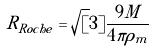Convert formula to latex. <formula><loc_0><loc_0><loc_500><loc_500>R _ { R o c h e } = \sqrt { [ } 3 ] { \frac { 9 M } { 4 \pi \rho _ { m } } }</formula> 